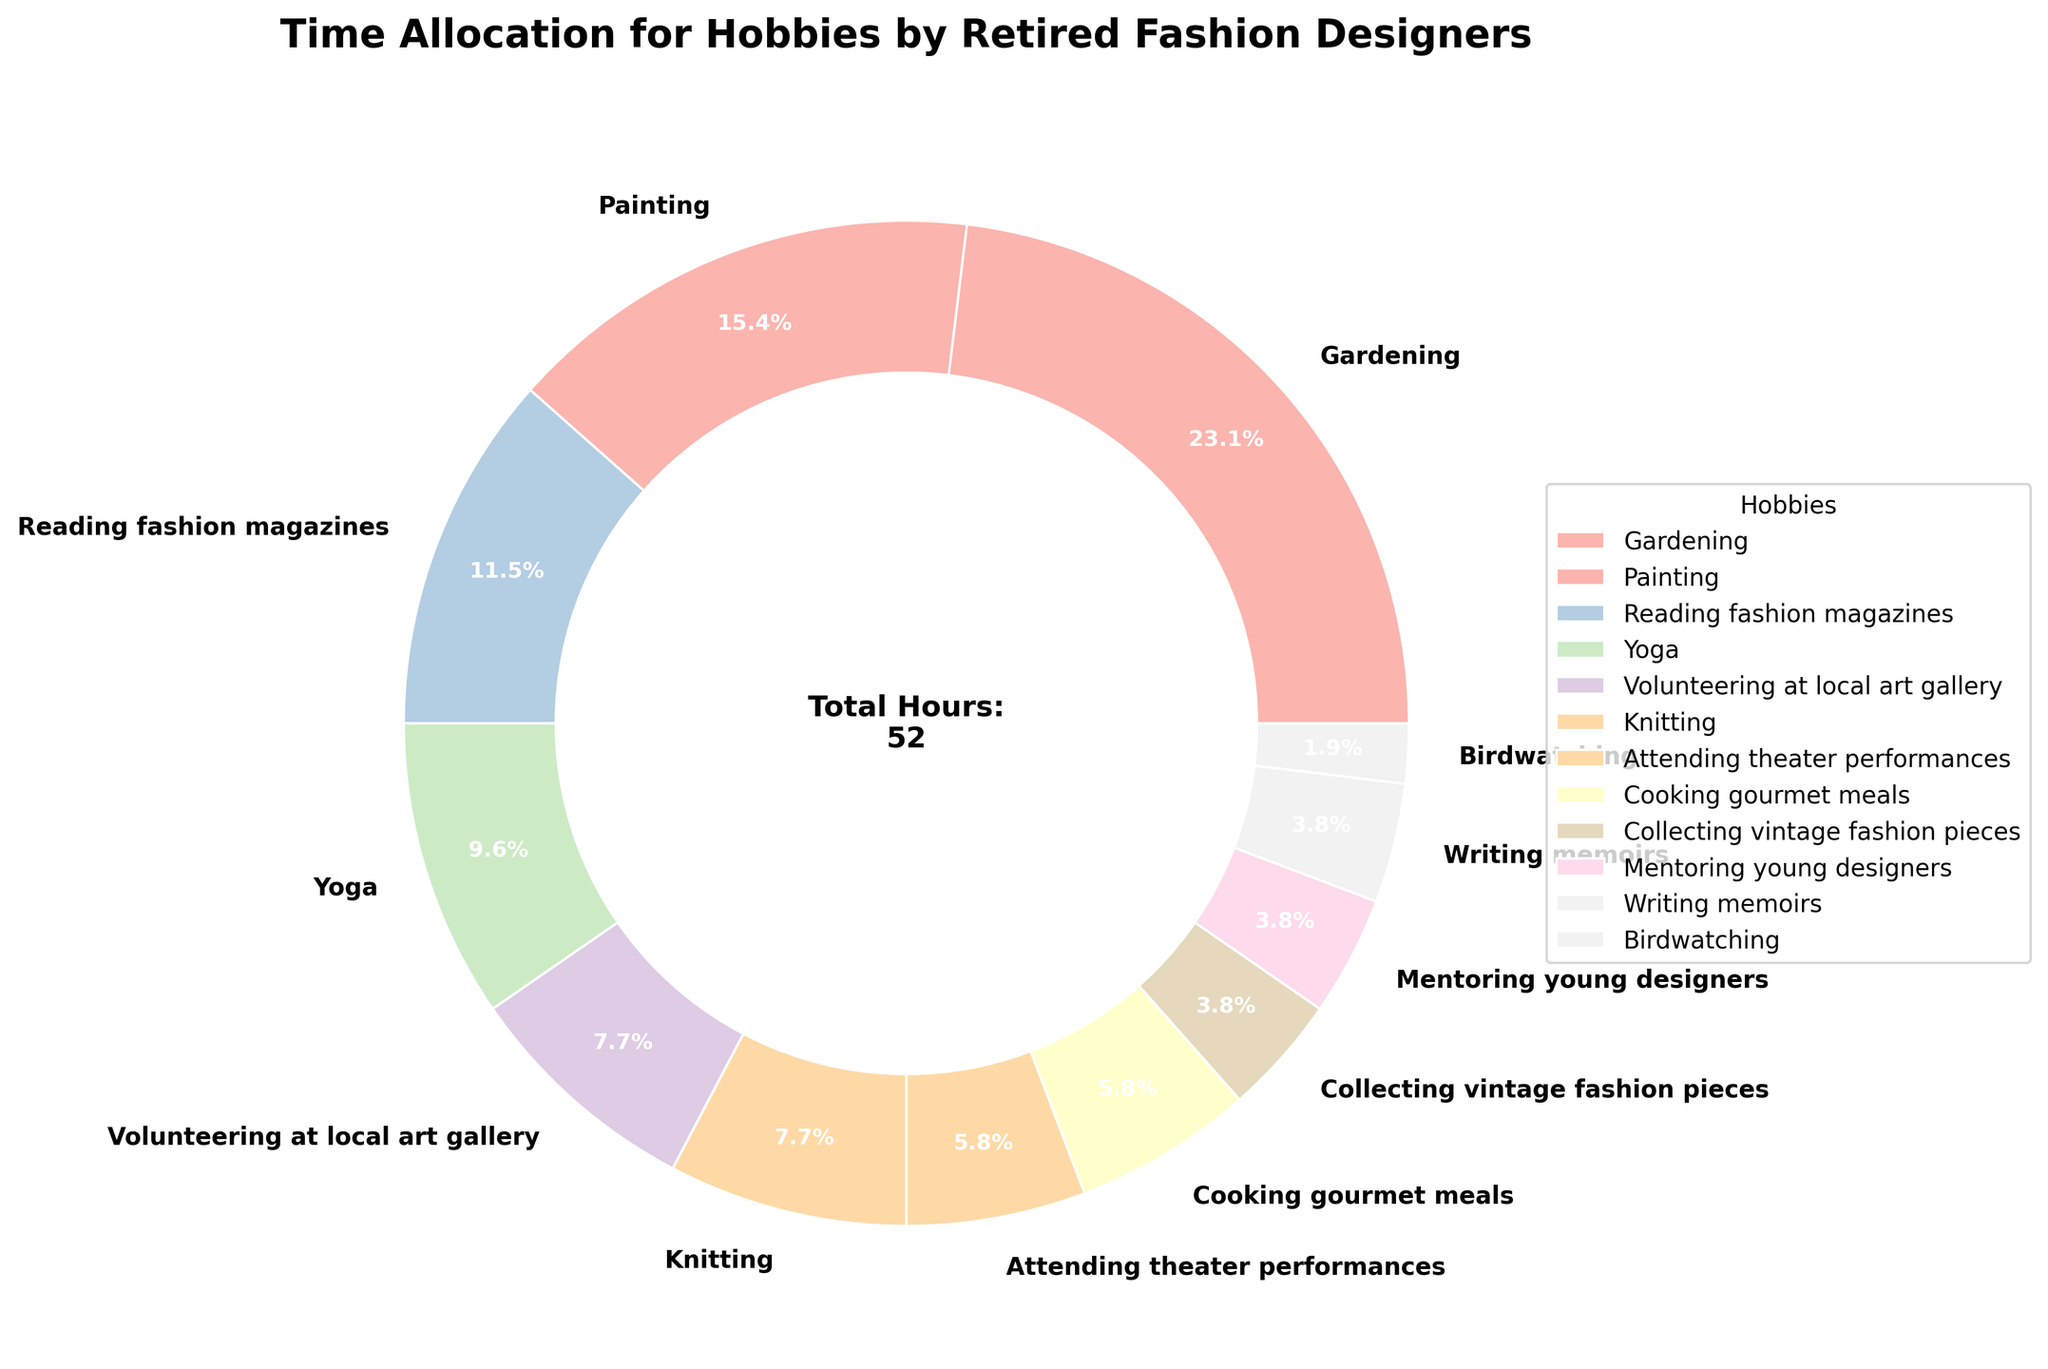How much time do retired fashion designers spend on cooking gourmet meals compared to gardening? Gardening occupies 12 hours per week, while cooking gourmet meals takes 3 hours per week. To find the difference, subtract the hours spent cooking from the hours spent gardening: 12 - 3 = 9 hours.
Answer: 9 hours What is the total time spent on knitting and mentoring young designers? Knitting takes 4 hours per week, and mentoring young designers takes 2 hours per week. Adding these together: 4 + 2 = 6 hours.
Answer: 6 hours How many hours per week do retired fashion designers dedicate to physical activities like yoga and birdwatching? Yoga takes 5 hours per week, and birdwatching takes 1 hour per week. Summing these hours gives 5 + 1 = 6 hours.
Answer: 6 hours Which hobby occupies the smallest amount of time, and how many hours is it? The hobby that occupies the smallest amount of time is birdwatching, which takes 1 hour per week.
Answer: Birdwatching, 1 hour What percentage of their time do retired fashion designers spend on painting and volunteering at a local art gallery combined? Painting takes 8 hours per week and volunteering at the local art gallery takes 4 hours per week. The combined total is 8 + 4 = 12 hours. The full week consists of 52 hours (sum of all hobby hours). The percentage is (12 / 52) * 100 ≈ 23.1%.
Answer: 23.1% Which hobby uses a darker shade of pastel in the pie chart vision? The color representation can vary with the theme used, but generally, darker shades of pastels are usually assigned by the sequence and the shades. In this scenario, darker colors are relative but typically, hobbies with larger slices like gardening or painting may appear with a more noticeable pastel hue.
Answer: Gardening or Painting Is more time spent on reading fashion magazines or mentoring young designers? Reading fashion magazines takes 6 hours per week, while mentoring young designers takes 2 hours per week. Therefore, more time is spent reading fashion magazines.
Answer: Reading fashion magazines Calculate the difference in time spent on attending theater performances and collecting vintage fashion pieces. Attending theater performances takes 3 hours per week, and collecting vintage fashion pieces takes 2 hours per week. The difference is 3 - 2 = 1 hour.
Answer: 1 hour How does the time spent on yoga compare to the time spent on painting? Yoga takes 5 hours per week, while painting takes 8 hours per week. Painting takes 3 more hours per week than yoga.
Answer: 3 hours more 